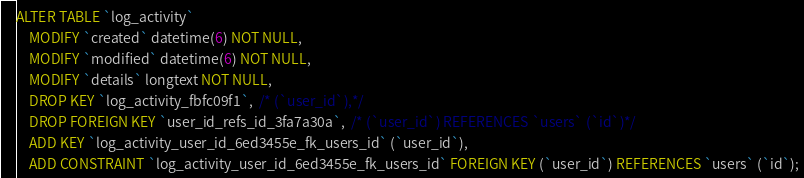<code> <loc_0><loc_0><loc_500><loc_500><_SQL_>ALTER TABLE `log_activity`
    MODIFY `created` datetime(6) NOT NULL,
    MODIFY `modified` datetime(6) NOT NULL,
    MODIFY `details` longtext NOT NULL,
    DROP KEY `log_activity_fbfc09f1`,  /* (`user_id`),*/
    DROP FOREIGN KEY `user_id_refs_id_3fa7a30a`,  /* (`user_id`) REFERENCES `users` (`id`)*/
    ADD KEY `log_activity_user_id_6ed3455e_fk_users_id` (`user_id`),
    ADD CONSTRAINT `log_activity_user_id_6ed3455e_fk_users_id` FOREIGN KEY (`user_id`) REFERENCES `users` (`id`);
</code> 